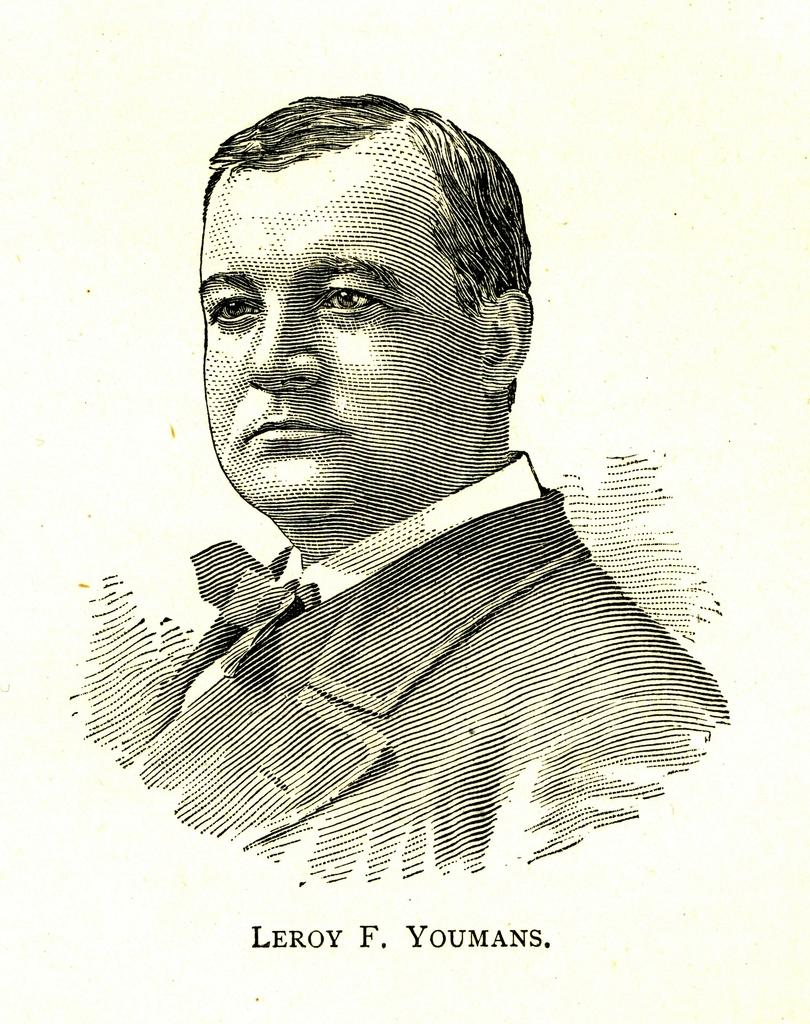What is depicted in the image? There is a drawing of a person in the image. Are there any additional elements in the image besides the drawing of the person? Yes, there are alphabets at the bottom of the image. How many bikes are parked next to the person in the image? There are no bikes present in the image; it only features a drawing of a person and alphabets at the bottom. 